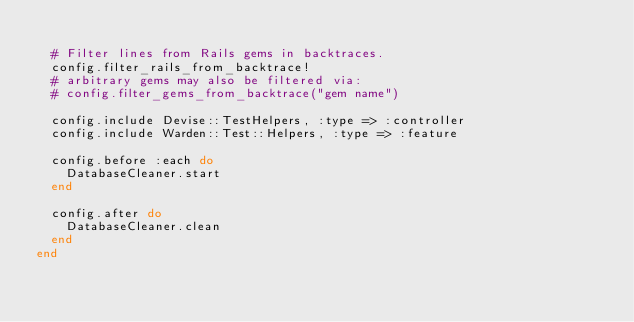<code> <loc_0><loc_0><loc_500><loc_500><_Ruby_>
  # Filter lines from Rails gems in backtraces.
  config.filter_rails_from_backtrace!
  # arbitrary gems may also be filtered via:
  # config.filter_gems_from_backtrace("gem name")

  config.include Devise::TestHelpers, :type => :controller
  config.include Warden::Test::Helpers, :type => :feature

  config.before :each do
    DatabaseCleaner.start
  end

  config.after do
    DatabaseCleaner.clean
  end
end
</code> 